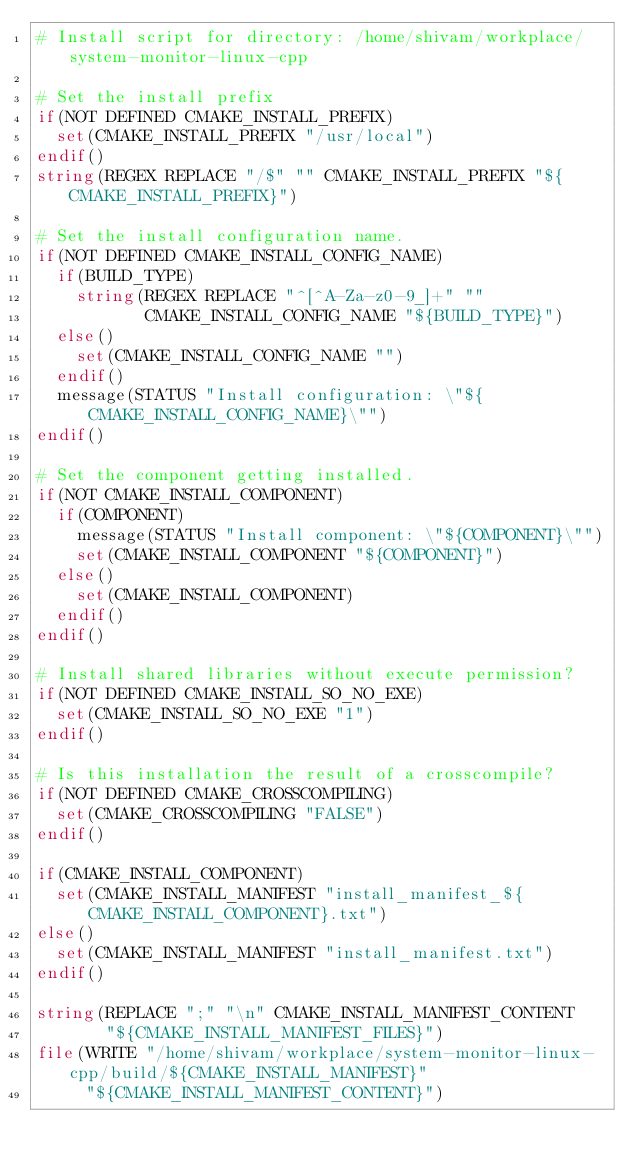Convert code to text. <code><loc_0><loc_0><loc_500><loc_500><_CMake_># Install script for directory: /home/shivam/workplace/system-monitor-linux-cpp

# Set the install prefix
if(NOT DEFINED CMAKE_INSTALL_PREFIX)
  set(CMAKE_INSTALL_PREFIX "/usr/local")
endif()
string(REGEX REPLACE "/$" "" CMAKE_INSTALL_PREFIX "${CMAKE_INSTALL_PREFIX}")

# Set the install configuration name.
if(NOT DEFINED CMAKE_INSTALL_CONFIG_NAME)
  if(BUILD_TYPE)
    string(REGEX REPLACE "^[^A-Za-z0-9_]+" ""
           CMAKE_INSTALL_CONFIG_NAME "${BUILD_TYPE}")
  else()
    set(CMAKE_INSTALL_CONFIG_NAME "")
  endif()
  message(STATUS "Install configuration: \"${CMAKE_INSTALL_CONFIG_NAME}\"")
endif()

# Set the component getting installed.
if(NOT CMAKE_INSTALL_COMPONENT)
  if(COMPONENT)
    message(STATUS "Install component: \"${COMPONENT}\"")
    set(CMAKE_INSTALL_COMPONENT "${COMPONENT}")
  else()
    set(CMAKE_INSTALL_COMPONENT)
  endif()
endif()

# Install shared libraries without execute permission?
if(NOT DEFINED CMAKE_INSTALL_SO_NO_EXE)
  set(CMAKE_INSTALL_SO_NO_EXE "1")
endif()

# Is this installation the result of a crosscompile?
if(NOT DEFINED CMAKE_CROSSCOMPILING)
  set(CMAKE_CROSSCOMPILING "FALSE")
endif()

if(CMAKE_INSTALL_COMPONENT)
  set(CMAKE_INSTALL_MANIFEST "install_manifest_${CMAKE_INSTALL_COMPONENT}.txt")
else()
  set(CMAKE_INSTALL_MANIFEST "install_manifest.txt")
endif()

string(REPLACE ";" "\n" CMAKE_INSTALL_MANIFEST_CONTENT
       "${CMAKE_INSTALL_MANIFEST_FILES}")
file(WRITE "/home/shivam/workplace/system-monitor-linux-cpp/build/${CMAKE_INSTALL_MANIFEST}"
     "${CMAKE_INSTALL_MANIFEST_CONTENT}")
</code> 